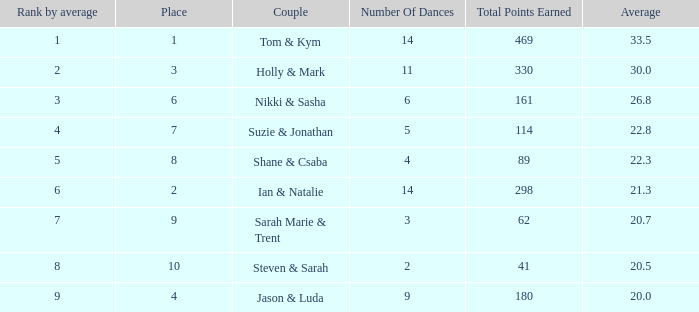If the total score achieved by the couple is 161, what are their names? Nikki & Sasha. 